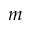<formula> <loc_0><loc_0><loc_500><loc_500>m</formula> 